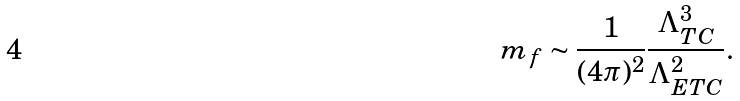<formula> <loc_0><loc_0><loc_500><loc_500>m _ { f } \sim \frac { 1 } { ( 4 \pi ) ^ { 2 } } \frac { \Lambda _ { T C } ^ { 3 } } { \Lambda _ { E T C } ^ { 2 } } .</formula> 